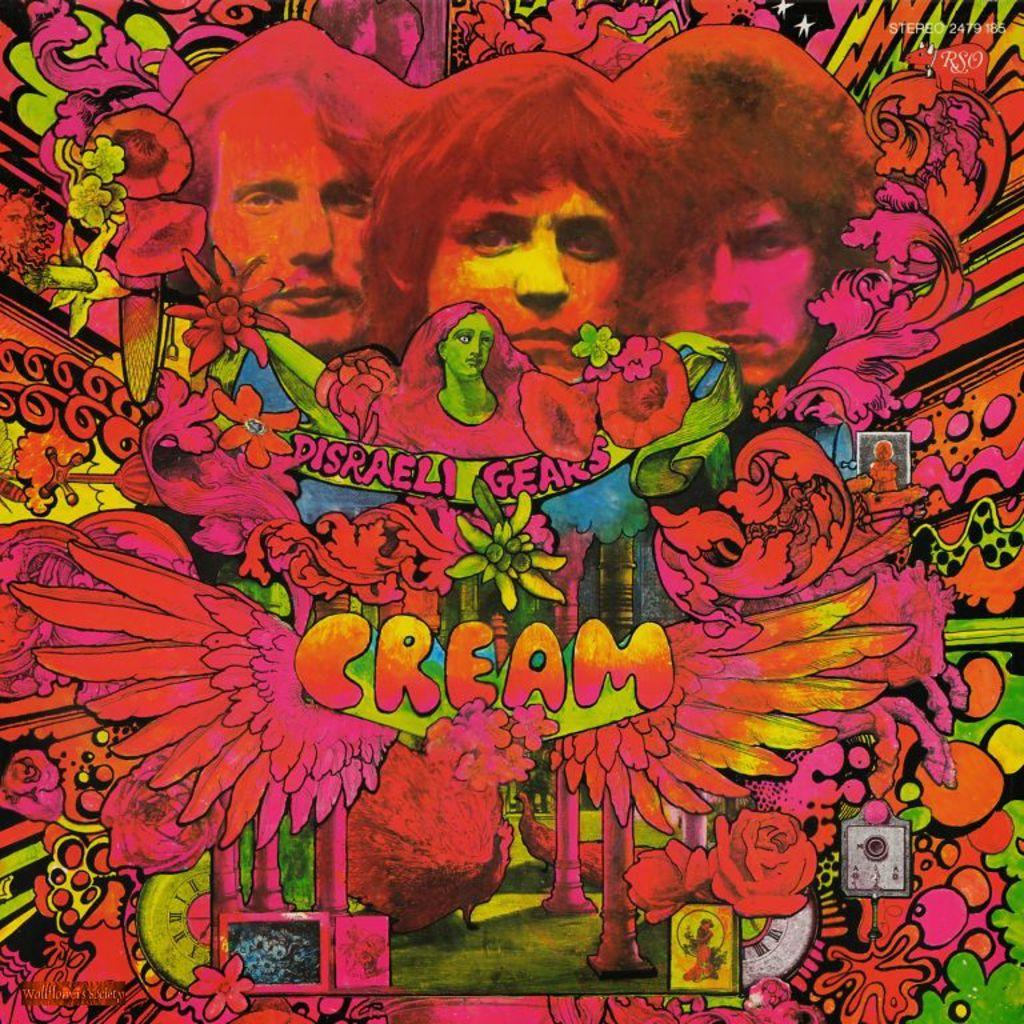Provide a one-sentence caption for the provided image. A bright neon colored sign that says Disreali Gears Cream. 